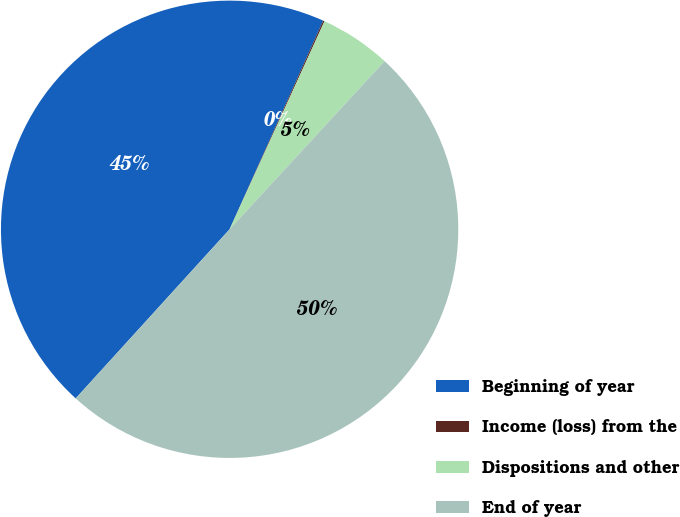Convert chart to OTSL. <chart><loc_0><loc_0><loc_500><loc_500><pie_chart><fcel>Beginning of year<fcel>Income (loss) from the<fcel>Dispositions and other<fcel>End of year<nl><fcel>44.96%<fcel>0.1%<fcel>5.04%<fcel>49.9%<nl></chart> 